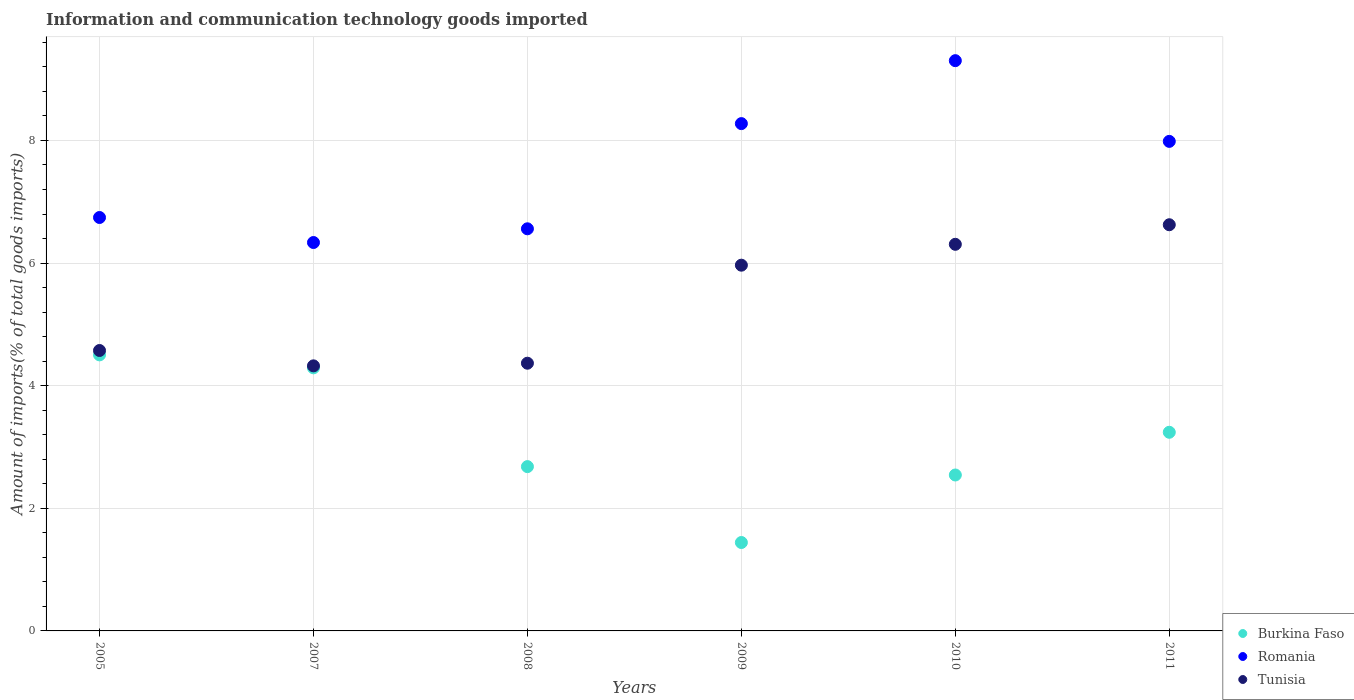How many different coloured dotlines are there?
Keep it short and to the point. 3. What is the amount of goods imported in Tunisia in 2005?
Your answer should be compact. 4.57. Across all years, what is the maximum amount of goods imported in Tunisia?
Provide a short and direct response. 6.63. Across all years, what is the minimum amount of goods imported in Romania?
Provide a short and direct response. 6.34. What is the total amount of goods imported in Romania in the graph?
Offer a terse response. 45.2. What is the difference between the amount of goods imported in Tunisia in 2008 and that in 2009?
Your answer should be very brief. -1.6. What is the difference between the amount of goods imported in Burkina Faso in 2011 and the amount of goods imported in Tunisia in 2010?
Provide a succinct answer. -3.07. What is the average amount of goods imported in Romania per year?
Provide a short and direct response. 7.53. In the year 2005, what is the difference between the amount of goods imported in Burkina Faso and amount of goods imported in Romania?
Provide a succinct answer. -2.24. In how many years, is the amount of goods imported in Romania greater than 1.2000000000000002 %?
Your response must be concise. 6. What is the ratio of the amount of goods imported in Romania in 2009 to that in 2011?
Provide a succinct answer. 1.04. Is the amount of goods imported in Burkina Faso in 2005 less than that in 2008?
Your response must be concise. No. Is the difference between the amount of goods imported in Burkina Faso in 2008 and 2011 greater than the difference between the amount of goods imported in Romania in 2008 and 2011?
Offer a terse response. Yes. What is the difference between the highest and the second highest amount of goods imported in Burkina Faso?
Give a very brief answer. 0.21. What is the difference between the highest and the lowest amount of goods imported in Burkina Faso?
Provide a succinct answer. 3.06. Is the sum of the amount of goods imported in Burkina Faso in 2005 and 2008 greater than the maximum amount of goods imported in Romania across all years?
Ensure brevity in your answer.  No. Does the amount of goods imported in Burkina Faso monotonically increase over the years?
Keep it short and to the point. No. Is the amount of goods imported in Tunisia strictly less than the amount of goods imported in Burkina Faso over the years?
Provide a succinct answer. No. How many dotlines are there?
Offer a terse response. 3. What is the difference between two consecutive major ticks on the Y-axis?
Ensure brevity in your answer.  2. Are the values on the major ticks of Y-axis written in scientific E-notation?
Keep it short and to the point. No. Where does the legend appear in the graph?
Provide a short and direct response. Bottom right. How many legend labels are there?
Provide a succinct answer. 3. What is the title of the graph?
Give a very brief answer. Information and communication technology goods imported. What is the label or title of the Y-axis?
Keep it short and to the point. Amount of imports(% of total goods imports). What is the Amount of imports(% of total goods imports) in Burkina Faso in 2005?
Make the answer very short. 4.5. What is the Amount of imports(% of total goods imports) of Romania in 2005?
Your answer should be compact. 6.74. What is the Amount of imports(% of total goods imports) of Tunisia in 2005?
Make the answer very short. 4.57. What is the Amount of imports(% of total goods imports) in Burkina Faso in 2007?
Offer a very short reply. 4.29. What is the Amount of imports(% of total goods imports) of Romania in 2007?
Keep it short and to the point. 6.34. What is the Amount of imports(% of total goods imports) of Tunisia in 2007?
Your answer should be compact. 4.32. What is the Amount of imports(% of total goods imports) of Burkina Faso in 2008?
Give a very brief answer. 2.68. What is the Amount of imports(% of total goods imports) of Romania in 2008?
Give a very brief answer. 6.56. What is the Amount of imports(% of total goods imports) in Tunisia in 2008?
Give a very brief answer. 4.37. What is the Amount of imports(% of total goods imports) of Burkina Faso in 2009?
Provide a succinct answer. 1.44. What is the Amount of imports(% of total goods imports) of Romania in 2009?
Offer a very short reply. 8.27. What is the Amount of imports(% of total goods imports) of Tunisia in 2009?
Your response must be concise. 5.97. What is the Amount of imports(% of total goods imports) in Burkina Faso in 2010?
Make the answer very short. 2.54. What is the Amount of imports(% of total goods imports) of Romania in 2010?
Your answer should be very brief. 9.3. What is the Amount of imports(% of total goods imports) in Tunisia in 2010?
Your answer should be very brief. 6.31. What is the Amount of imports(% of total goods imports) in Burkina Faso in 2011?
Your response must be concise. 3.24. What is the Amount of imports(% of total goods imports) in Romania in 2011?
Your response must be concise. 7.98. What is the Amount of imports(% of total goods imports) of Tunisia in 2011?
Your response must be concise. 6.63. Across all years, what is the maximum Amount of imports(% of total goods imports) in Burkina Faso?
Make the answer very short. 4.5. Across all years, what is the maximum Amount of imports(% of total goods imports) in Romania?
Your answer should be very brief. 9.3. Across all years, what is the maximum Amount of imports(% of total goods imports) of Tunisia?
Give a very brief answer. 6.63. Across all years, what is the minimum Amount of imports(% of total goods imports) of Burkina Faso?
Offer a terse response. 1.44. Across all years, what is the minimum Amount of imports(% of total goods imports) of Romania?
Keep it short and to the point. 6.34. Across all years, what is the minimum Amount of imports(% of total goods imports) in Tunisia?
Make the answer very short. 4.32. What is the total Amount of imports(% of total goods imports) of Burkina Faso in the graph?
Offer a very short reply. 18.7. What is the total Amount of imports(% of total goods imports) of Romania in the graph?
Provide a succinct answer. 45.2. What is the total Amount of imports(% of total goods imports) of Tunisia in the graph?
Provide a short and direct response. 32.16. What is the difference between the Amount of imports(% of total goods imports) in Burkina Faso in 2005 and that in 2007?
Make the answer very short. 0.21. What is the difference between the Amount of imports(% of total goods imports) in Romania in 2005 and that in 2007?
Provide a succinct answer. 0.41. What is the difference between the Amount of imports(% of total goods imports) in Tunisia in 2005 and that in 2007?
Provide a short and direct response. 0.25. What is the difference between the Amount of imports(% of total goods imports) in Burkina Faso in 2005 and that in 2008?
Offer a very short reply. 1.82. What is the difference between the Amount of imports(% of total goods imports) of Romania in 2005 and that in 2008?
Give a very brief answer. 0.18. What is the difference between the Amount of imports(% of total goods imports) of Tunisia in 2005 and that in 2008?
Offer a very short reply. 0.21. What is the difference between the Amount of imports(% of total goods imports) in Burkina Faso in 2005 and that in 2009?
Provide a short and direct response. 3.06. What is the difference between the Amount of imports(% of total goods imports) in Romania in 2005 and that in 2009?
Offer a very short reply. -1.53. What is the difference between the Amount of imports(% of total goods imports) of Tunisia in 2005 and that in 2009?
Keep it short and to the point. -1.39. What is the difference between the Amount of imports(% of total goods imports) in Burkina Faso in 2005 and that in 2010?
Your response must be concise. 1.96. What is the difference between the Amount of imports(% of total goods imports) of Romania in 2005 and that in 2010?
Provide a short and direct response. -2.56. What is the difference between the Amount of imports(% of total goods imports) in Tunisia in 2005 and that in 2010?
Offer a very short reply. -1.73. What is the difference between the Amount of imports(% of total goods imports) in Burkina Faso in 2005 and that in 2011?
Your answer should be compact. 1.26. What is the difference between the Amount of imports(% of total goods imports) of Romania in 2005 and that in 2011?
Your answer should be compact. -1.24. What is the difference between the Amount of imports(% of total goods imports) of Tunisia in 2005 and that in 2011?
Keep it short and to the point. -2.05. What is the difference between the Amount of imports(% of total goods imports) of Burkina Faso in 2007 and that in 2008?
Offer a very short reply. 1.61. What is the difference between the Amount of imports(% of total goods imports) in Romania in 2007 and that in 2008?
Your answer should be very brief. -0.22. What is the difference between the Amount of imports(% of total goods imports) of Tunisia in 2007 and that in 2008?
Offer a very short reply. -0.04. What is the difference between the Amount of imports(% of total goods imports) of Burkina Faso in 2007 and that in 2009?
Offer a very short reply. 2.85. What is the difference between the Amount of imports(% of total goods imports) in Romania in 2007 and that in 2009?
Ensure brevity in your answer.  -1.94. What is the difference between the Amount of imports(% of total goods imports) in Tunisia in 2007 and that in 2009?
Your response must be concise. -1.64. What is the difference between the Amount of imports(% of total goods imports) of Burkina Faso in 2007 and that in 2010?
Offer a very short reply. 1.75. What is the difference between the Amount of imports(% of total goods imports) in Romania in 2007 and that in 2010?
Provide a succinct answer. -2.97. What is the difference between the Amount of imports(% of total goods imports) in Tunisia in 2007 and that in 2010?
Ensure brevity in your answer.  -1.98. What is the difference between the Amount of imports(% of total goods imports) in Burkina Faso in 2007 and that in 2011?
Your answer should be compact. 1.05. What is the difference between the Amount of imports(% of total goods imports) of Romania in 2007 and that in 2011?
Ensure brevity in your answer.  -1.65. What is the difference between the Amount of imports(% of total goods imports) of Tunisia in 2007 and that in 2011?
Your answer should be compact. -2.3. What is the difference between the Amount of imports(% of total goods imports) of Burkina Faso in 2008 and that in 2009?
Provide a succinct answer. 1.24. What is the difference between the Amount of imports(% of total goods imports) of Romania in 2008 and that in 2009?
Provide a short and direct response. -1.72. What is the difference between the Amount of imports(% of total goods imports) in Tunisia in 2008 and that in 2009?
Provide a succinct answer. -1.6. What is the difference between the Amount of imports(% of total goods imports) of Burkina Faso in 2008 and that in 2010?
Your response must be concise. 0.14. What is the difference between the Amount of imports(% of total goods imports) in Romania in 2008 and that in 2010?
Provide a short and direct response. -2.74. What is the difference between the Amount of imports(% of total goods imports) of Tunisia in 2008 and that in 2010?
Keep it short and to the point. -1.94. What is the difference between the Amount of imports(% of total goods imports) in Burkina Faso in 2008 and that in 2011?
Provide a short and direct response. -0.56. What is the difference between the Amount of imports(% of total goods imports) of Romania in 2008 and that in 2011?
Provide a succinct answer. -1.43. What is the difference between the Amount of imports(% of total goods imports) of Tunisia in 2008 and that in 2011?
Your answer should be very brief. -2.26. What is the difference between the Amount of imports(% of total goods imports) of Burkina Faso in 2009 and that in 2010?
Offer a terse response. -1.1. What is the difference between the Amount of imports(% of total goods imports) in Romania in 2009 and that in 2010?
Offer a very short reply. -1.03. What is the difference between the Amount of imports(% of total goods imports) of Tunisia in 2009 and that in 2010?
Provide a short and direct response. -0.34. What is the difference between the Amount of imports(% of total goods imports) in Burkina Faso in 2009 and that in 2011?
Provide a succinct answer. -1.8. What is the difference between the Amount of imports(% of total goods imports) in Romania in 2009 and that in 2011?
Ensure brevity in your answer.  0.29. What is the difference between the Amount of imports(% of total goods imports) in Tunisia in 2009 and that in 2011?
Your answer should be very brief. -0.66. What is the difference between the Amount of imports(% of total goods imports) of Burkina Faso in 2010 and that in 2011?
Keep it short and to the point. -0.7. What is the difference between the Amount of imports(% of total goods imports) in Romania in 2010 and that in 2011?
Make the answer very short. 1.32. What is the difference between the Amount of imports(% of total goods imports) of Tunisia in 2010 and that in 2011?
Your answer should be compact. -0.32. What is the difference between the Amount of imports(% of total goods imports) of Burkina Faso in 2005 and the Amount of imports(% of total goods imports) of Romania in 2007?
Your answer should be compact. -1.83. What is the difference between the Amount of imports(% of total goods imports) of Burkina Faso in 2005 and the Amount of imports(% of total goods imports) of Tunisia in 2007?
Offer a terse response. 0.18. What is the difference between the Amount of imports(% of total goods imports) in Romania in 2005 and the Amount of imports(% of total goods imports) in Tunisia in 2007?
Keep it short and to the point. 2.42. What is the difference between the Amount of imports(% of total goods imports) in Burkina Faso in 2005 and the Amount of imports(% of total goods imports) in Romania in 2008?
Offer a very short reply. -2.06. What is the difference between the Amount of imports(% of total goods imports) of Burkina Faso in 2005 and the Amount of imports(% of total goods imports) of Tunisia in 2008?
Give a very brief answer. 0.14. What is the difference between the Amount of imports(% of total goods imports) in Romania in 2005 and the Amount of imports(% of total goods imports) in Tunisia in 2008?
Give a very brief answer. 2.38. What is the difference between the Amount of imports(% of total goods imports) in Burkina Faso in 2005 and the Amount of imports(% of total goods imports) in Romania in 2009?
Offer a terse response. -3.77. What is the difference between the Amount of imports(% of total goods imports) of Burkina Faso in 2005 and the Amount of imports(% of total goods imports) of Tunisia in 2009?
Your response must be concise. -1.46. What is the difference between the Amount of imports(% of total goods imports) in Romania in 2005 and the Amount of imports(% of total goods imports) in Tunisia in 2009?
Make the answer very short. 0.78. What is the difference between the Amount of imports(% of total goods imports) in Burkina Faso in 2005 and the Amount of imports(% of total goods imports) in Romania in 2010?
Your response must be concise. -4.8. What is the difference between the Amount of imports(% of total goods imports) of Burkina Faso in 2005 and the Amount of imports(% of total goods imports) of Tunisia in 2010?
Your answer should be compact. -1.8. What is the difference between the Amount of imports(% of total goods imports) in Romania in 2005 and the Amount of imports(% of total goods imports) in Tunisia in 2010?
Your response must be concise. 0.44. What is the difference between the Amount of imports(% of total goods imports) of Burkina Faso in 2005 and the Amount of imports(% of total goods imports) of Romania in 2011?
Ensure brevity in your answer.  -3.48. What is the difference between the Amount of imports(% of total goods imports) in Burkina Faso in 2005 and the Amount of imports(% of total goods imports) in Tunisia in 2011?
Give a very brief answer. -2.12. What is the difference between the Amount of imports(% of total goods imports) of Romania in 2005 and the Amount of imports(% of total goods imports) of Tunisia in 2011?
Keep it short and to the point. 0.12. What is the difference between the Amount of imports(% of total goods imports) in Burkina Faso in 2007 and the Amount of imports(% of total goods imports) in Romania in 2008?
Your answer should be compact. -2.27. What is the difference between the Amount of imports(% of total goods imports) in Burkina Faso in 2007 and the Amount of imports(% of total goods imports) in Tunisia in 2008?
Ensure brevity in your answer.  -0.08. What is the difference between the Amount of imports(% of total goods imports) of Romania in 2007 and the Amount of imports(% of total goods imports) of Tunisia in 2008?
Offer a very short reply. 1.97. What is the difference between the Amount of imports(% of total goods imports) of Burkina Faso in 2007 and the Amount of imports(% of total goods imports) of Romania in 2009?
Offer a very short reply. -3.98. What is the difference between the Amount of imports(% of total goods imports) of Burkina Faso in 2007 and the Amount of imports(% of total goods imports) of Tunisia in 2009?
Your answer should be very brief. -1.67. What is the difference between the Amount of imports(% of total goods imports) of Romania in 2007 and the Amount of imports(% of total goods imports) of Tunisia in 2009?
Ensure brevity in your answer.  0.37. What is the difference between the Amount of imports(% of total goods imports) in Burkina Faso in 2007 and the Amount of imports(% of total goods imports) in Romania in 2010?
Provide a short and direct response. -5.01. What is the difference between the Amount of imports(% of total goods imports) of Burkina Faso in 2007 and the Amount of imports(% of total goods imports) of Tunisia in 2010?
Make the answer very short. -2.01. What is the difference between the Amount of imports(% of total goods imports) of Romania in 2007 and the Amount of imports(% of total goods imports) of Tunisia in 2010?
Make the answer very short. 0.03. What is the difference between the Amount of imports(% of total goods imports) of Burkina Faso in 2007 and the Amount of imports(% of total goods imports) of Romania in 2011?
Provide a succinct answer. -3.69. What is the difference between the Amount of imports(% of total goods imports) in Burkina Faso in 2007 and the Amount of imports(% of total goods imports) in Tunisia in 2011?
Your response must be concise. -2.33. What is the difference between the Amount of imports(% of total goods imports) of Romania in 2007 and the Amount of imports(% of total goods imports) of Tunisia in 2011?
Provide a short and direct response. -0.29. What is the difference between the Amount of imports(% of total goods imports) of Burkina Faso in 2008 and the Amount of imports(% of total goods imports) of Romania in 2009?
Provide a short and direct response. -5.59. What is the difference between the Amount of imports(% of total goods imports) of Burkina Faso in 2008 and the Amount of imports(% of total goods imports) of Tunisia in 2009?
Offer a terse response. -3.29. What is the difference between the Amount of imports(% of total goods imports) in Romania in 2008 and the Amount of imports(% of total goods imports) in Tunisia in 2009?
Your answer should be compact. 0.59. What is the difference between the Amount of imports(% of total goods imports) of Burkina Faso in 2008 and the Amount of imports(% of total goods imports) of Romania in 2010?
Give a very brief answer. -6.62. What is the difference between the Amount of imports(% of total goods imports) in Burkina Faso in 2008 and the Amount of imports(% of total goods imports) in Tunisia in 2010?
Give a very brief answer. -3.63. What is the difference between the Amount of imports(% of total goods imports) of Romania in 2008 and the Amount of imports(% of total goods imports) of Tunisia in 2010?
Your response must be concise. 0.25. What is the difference between the Amount of imports(% of total goods imports) in Burkina Faso in 2008 and the Amount of imports(% of total goods imports) in Romania in 2011?
Provide a succinct answer. -5.3. What is the difference between the Amount of imports(% of total goods imports) of Burkina Faso in 2008 and the Amount of imports(% of total goods imports) of Tunisia in 2011?
Ensure brevity in your answer.  -3.95. What is the difference between the Amount of imports(% of total goods imports) in Romania in 2008 and the Amount of imports(% of total goods imports) in Tunisia in 2011?
Your answer should be compact. -0.07. What is the difference between the Amount of imports(% of total goods imports) in Burkina Faso in 2009 and the Amount of imports(% of total goods imports) in Romania in 2010?
Offer a terse response. -7.86. What is the difference between the Amount of imports(% of total goods imports) of Burkina Faso in 2009 and the Amount of imports(% of total goods imports) of Tunisia in 2010?
Give a very brief answer. -4.86. What is the difference between the Amount of imports(% of total goods imports) in Romania in 2009 and the Amount of imports(% of total goods imports) in Tunisia in 2010?
Make the answer very short. 1.97. What is the difference between the Amount of imports(% of total goods imports) in Burkina Faso in 2009 and the Amount of imports(% of total goods imports) in Romania in 2011?
Offer a terse response. -6.54. What is the difference between the Amount of imports(% of total goods imports) in Burkina Faso in 2009 and the Amount of imports(% of total goods imports) in Tunisia in 2011?
Your answer should be very brief. -5.18. What is the difference between the Amount of imports(% of total goods imports) of Romania in 2009 and the Amount of imports(% of total goods imports) of Tunisia in 2011?
Your answer should be compact. 1.65. What is the difference between the Amount of imports(% of total goods imports) in Burkina Faso in 2010 and the Amount of imports(% of total goods imports) in Romania in 2011?
Provide a short and direct response. -5.44. What is the difference between the Amount of imports(% of total goods imports) of Burkina Faso in 2010 and the Amount of imports(% of total goods imports) of Tunisia in 2011?
Your answer should be compact. -4.08. What is the difference between the Amount of imports(% of total goods imports) in Romania in 2010 and the Amount of imports(% of total goods imports) in Tunisia in 2011?
Ensure brevity in your answer.  2.68. What is the average Amount of imports(% of total goods imports) of Burkina Faso per year?
Your response must be concise. 3.12. What is the average Amount of imports(% of total goods imports) in Romania per year?
Give a very brief answer. 7.53. What is the average Amount of imports(% of total goods imports) in Tunisia per year?
Your answer should be compact. 5.36. In the year 2005, what is the difference between the Amount of imports(% of total goods imports) in Burkina Faso and Amount of imports(% of total goods imports) in Romania?
Offer a very short reply. -2.24. In the year 2005, what is the difference between the Amount of imports(% of total goods imports) of Burkina Faso and Amount of imports(% of total goods imports) of Tunisia?
Offer a very short reply. -0.07. In the year 2005, what is the difference between the Amount of imports(% of total goods imports) in Romania and Amount of imports(% of total goods imports) in Tunisia?
Keep it short and to the point. 2.17. In the year 2007, what is the difference between the Amount of imports(% of total goods imports) in Burkina Faso and Amount of imports(% of total goods imports) in Romania?
Keep it short and to the point. -2.04. In the year 2007, what is the difference between the Amount of imports(% of total goods imports) of Burkina Faso and Amount of imports(% of total goods imports) of Tunisia?
Offer a terse response. -0.03. In the year 2007, what is the difference between the Amount of imports(% of total goods imports) of Romania and Amount of imports(% of total goods imports) of Tunisia?
Your answer should be compact. 2.01. In the year 2008, what is the difference between the Amount of imports(% of total goods imports) in Burkina Faso and Amount of imports(% of total goods imports) in Romania?
Give a very brief answer. -3.88. In the year 2008, what is the difference between the Amount of imports(% of total goods imports) of Burkina Faso and Amount of imports(% of total goods imports) of Tunisia?
Make the answer very short. -1.69. In the year 2008, what is the difference between the Amount of imports(% of total goods imports) in Romania and Amount of imports(% of total goods imports) in Tunisia?
Your answer should be compact. 2.19. In the year 2009, what is the difference between the Amount of imports(% of total goods imports) in Burkina Faso and Amount of imports(% of total goods imports) in Romania?
Provide a succinct answer. -6.83. In the year 2009, what is the difference between the Amount of imports(% of total goods imports) in Burkina Faso and Amount of imports(% of total goods imports) in Tunisia?
Offer a terse response. -4.52. In the year 2009, what is the difference between the Amount of imports(% of total goods imports) of Romania and Amount of imports(% of total goods imports) of Tunisia?
Provide a succinct answer. 2.31. In the year 2010, what is the difference between the Amount of imports(% of total goods imports) of Burkina Faso and Amount of imports(% of total goods imports) of Romania?
Your response must be concise. -6.76. In the year 2010, what is the difference between the Amount of imports(% of total goods imports) of Burkina Faso and Amount of imports(% of total goods imports) of Tunisia?
Offer a terse response. -3.76. In the year 2010, what is the difference between the Amount of imports(% of total goods imports) of Romania and Amount of imports(% of total goods imports) of Tunisia?
Give a very brief answer. 3. In the year 2011, what is the difference between the Amount of imports(% of total goods imports) in Burkina Faso and Amount of imports(% of total goods imports) in Romania?
Your answer should be very brief. -4.74. In the year 2011, what is the difference between the Amount of imports(% of total goods imports) of Burkina Faso and Amount of imports(% of total goods imports) of Tunisia?
Provide a succinct answer. -3.38. In the year 2011, what is the difference between the Amount of imports(% of total goods imports) of Romania and Amount of imports(% of total goods imports) of Tunisia?
Keep it short and to the point. 1.36. What is the ratio of the Amount of imports(% of total goods imports) in Burkina Faso in 2005 to that in 2007?
Your response must be concise. 1.05. What is the ratio of the Amount of imports(% of total goods imports) in Romania in 2005 to that in 2007?
Ensure brevity in your answer.  1.06. What is the ratio of the Amount of imports(% of total goods imports) of Tunisia in 2005 to that in 2007?
Keep it short and to the point. 1.06. What is the ratio of the Amount of imports(% of total goods imports) of Burkina Faso in 2005 to that in 2008?
Your answer should be very brief. 1.68. What is the ratio of the Amount of imports(% of total goods imports) of Romania in 2005 to that in 2008?
Provide a succinct answer. 1.03. What is the ratio of the Amount of imports(% of total goods imports) in Tunisia in 2005 to that in 2008?
Make the answer very short. 1.05. What is the ratio of the Amount of imports(% of total goods imports) of Burkina Faso in 2005 to that in 2009?
Offer a terse response. 3.12. What is the ratio of the Amount of imports(% of total goods imports) of Romania in 2005 to that in 2009?
Offer a terse response. 0.81. What is the ratio of the Amount of imports(% of total goods imports) in Tunisia in 2005 to that in 2009?
Your answer should be compact. 0.77. What is the ratio of the Amount of imports(% of total goods imports) of Burkina Faso in 2005 to that in 2010?
Ensure brevity in your answer.  1.77. What is the ratio of the Amount of imports(% of total goods imports) in Romania in 2005 to that in 2010?
Your response must be concise. 0.72. What is the ratio of the Amount of imports(% of total goods imports) of Tunisia in 2005 to that in 2010?
Offer a terse response. 0.73. What is the ratio of the Amount of imports(% of total goods imports) of Burkina Faso in 2005 to that in 2011?
Ensure brevity in your answer.  1.39. What is the ratio of the Amount of imports(% of total goods imports) of Romania in 2005 to that in 2011?
Offer a very short reply. 0.84. What is the ratio of the Amount of imports(% of total goods imports) in Tunisia in 2005 to that in 2011?
Your answer should be very brief. 0.69. What is the ratio of the Amount of imports(% of total goods imports) in Burkina Faso in 2007 to that in 2008?
Offer a very short reply. 1.6. What is the ratio of the Amount of imports(% of total goods imports) of Romania in 2007 to that in 2008?
Give a very brief answer. 0.97. What is the ratio of the Amount of imports(% of total goods imports) in Tunisia in 2007 to that in 2008?
Offer a very short reply. 0.99. What is the ratio of the Amount of imports(% of total goods imports) of Burkina Faso in 2007 to that in 2009?
Your answer should be very brief. 2.98. What is the ratio of the Amount of imports(% of total goods imports) in Romania in 2007 to that in 2009?
Give a very brief answer. 0.77. What is the ratio of the Amount of imports(% of total goods imports) of Tunisia in 2007 to that in 2009?
Offer a very short reply. 0.72. What is the ratio of the Amount of imports(% of total goods imports) of Burkina Faso in 2007 to that in 2010?
Your answer should be very brief. 1.69. What is the ratio of the Amount of imports(% of total goods imports) in Romania in 2007 to that in 2010?
Provide a short and direct response. 0.68. What is the ratio of the Amount of imports(% of total goods imports) of Tunisia in 2007 to that in 2010?
Your response must be concise. 0.69. What is the ratio of the Amount of imports(% of total goods imports) in Burkina Faso in 2007 to that in 2011?
Give a very brief answer. 1.32. What is the ratio of the Amount of imports(% of total goods imports) in Romania in 2007 to that in 2011?
Your response must be concise. 0.79. What is the ratio of the Amount of imports(% of total goods imports) of Tunisia in 2007 to that in 2011?
Offer a terse response. 0.65. What is the ratio of the Amount of imports(% of total goods imports) of Burkina Faso in 2008 to that in 2009?
Your answer should be very brief. 1.86. What is the ratio of the Amount of imports(% of total goods imports) of Romania in 2008 to that in 2009?
Keep it short and to the point. 0.79. What is the ratio of the Amount of imports(% of total goods imports) in Tunisia in 2008 to that in 2009?
Keep it short and to the point. 0.73. What is the ratio of the Amount of imports(% of total goods imports) in Burkina Faso in 2008 to that in 2010?
Ensure brevity in your answer.  1.05. What is the ratio of the Amount of imports(% of total goods imports) of Romania in 2008 to that in 2010?
Give a very brief answer. 0.71. What is the ratio of the Amount of imports(% of total goods imports) of Tunisia in 2008 to that in 2010?
Offer a very short reply. 0.69. What is the ratio of the Amount of imports(% of total goods imports) in Burkina Faso in 2008 to that in 2011?
Provide a succinct answer. 0.83. What is the ratio of the Amount of imports(% of total goods imports) in Romania in 2008 to that in 2011?
Your answer should be compact. 0.82. What is the ratio of the Amount of imports(% of total goods imports) in Tunisia in 2008 to that in 2011?
Offer a very short reply. 0.66. What is the ratio of the Amount of imports(% of total goods imports) of Burkina Faso in 2009 to that in 2010?
Offer a very short reply. 0.57. What is the ratio of the Amount of imports(% of total goods imports) in Romania in 2009 to that in 2010?
Your answer should be very brief. 0.89. What is the ratio of the Amount of imports(% of total goods imports) of Tunisia in 2009 to that in 2010?
Offer a terse response. 0.95. What is the ratio of the Amount of imports(% of total goods imports) of Burkina Faso in 2009 to that in 2011?
Your answer should be very brief. 0.45. What is the ratio of the Amount of imports(% of total goods imports) of Romania in 2009 to that in 2011?
Ensure brevity in your answer.  1.04. What is the ratio of the Amount of imports(% of total goods imports) in Tunisia in 2009 to that in 2011?
Ensure brevity in your answer.  0.9. What is the ratio of the Amount of imports(% of total goods imports) in Burkina Faso in 2010 to that in 2011?
Ensure brevity in your answer.  0.79. What is the ratio of the Amount of imports(% of total goods imports) of Romania in 2010 to that in 2011?
Offer a terse response. 1.16. What is the ratio of the Amount of imports(% of total goods imports) of Tunisia in 2010 to that in 2011?
Give a very brief answer. 0.95. What is the difference between the highest and the second highest Amount of imports(% of total goods imports) of Burkina Faso?
Give a very brief answer. 0.21. What is the difference between the highest and the second highest Amount of imports(% of total goods imports) of Romania?
Make the answer very short. 1.03. What is the difference between the highest and the second highest Amount of imports(% of total goods imports) of Tunisia?
Offer a very short reply. 0.32. What is the difference between the highest and the lowest Amount of imports(% of total goods imports) in Burkina Faso?
Your answer should be very brief. 3.06. What is the difference between the highest and the lowest Amount of imports(% of total goods imports) in Romania?
Your answer should be very brief. 2.97. What is the difference between the highest and the lowest Amount of imports(% of total goods imports) in Tunisia?
Offer a terse response. 2.3. 